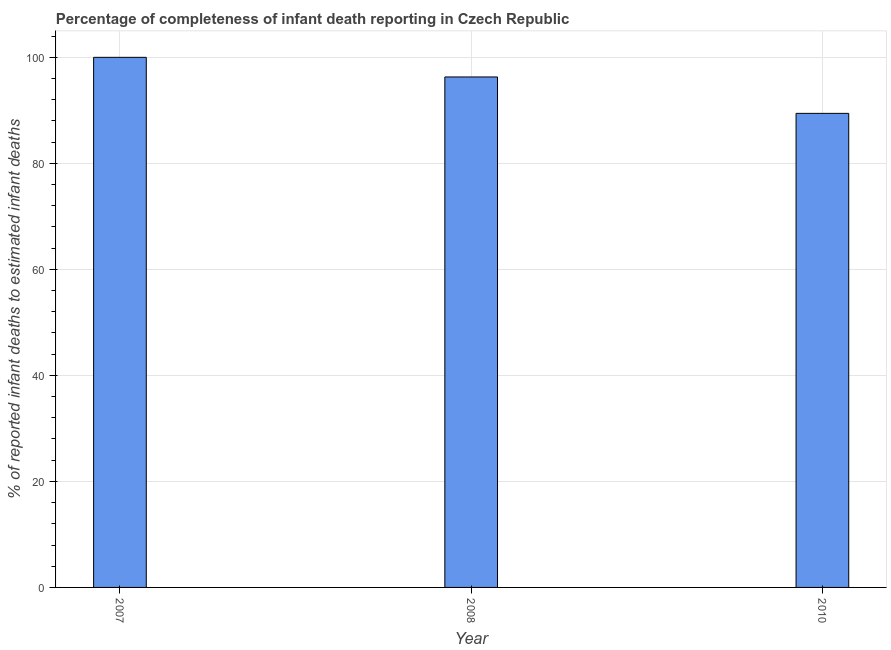Does the graph contain grids?
Keep it short and to the point. Yes. What is the title of the graph?
Offer a very short reply. Percentage of completeness of infant death reporting in Czech Republic. What is the label or title of the Y-axis?
Provide a short and direct response. % of reported infant deaths to estimated infant deaths. What is the completeness of infant death reporting in 2010?
Offer a very short reply. 89.43. Across all years, what is the maximum completeness of infant death reporting?
Ensure brevity in your answer.  100. Across all years, what is the minimum completeness of infant death reporting?
Your response must be concise. 89.43. In which year was the completeness of infant death reporting minimum?
Make the answer very short. 2010. What is the sum of the completeness of infant death reporting?
Offer a terse response. 285.72. What is the difference between the completeness of infant death reporting in 2007 and 2010?
Ensure brevity in your answer.  10.57. What is the average completeness of infant death reporting per year?
Your answer should be very brief. 95.24. What is the median completeness of infant death reporting?
Ensure brevity in your answer.  96.3. Do a majority of the years between 2008 and 2010 (inclusive) have completeness of infant death reporting greater than 64 %?
Provide a succinct answer. Yes. What is the ratio of the completeness of infant death reporting in 2007 to that in 2008?
Provide a succinct answer. 1.04. Is the difference between the completeness of infant death reporting in 2008 and 2010 greater than the difference between any two years?
Offer a very short reply. No. What is the difference between the highest and the second highest completeness of infant death reporting?
Your answer should be very brief. 3.7. Is the sum of the completeness of infant death reporting in 2007 and 2010 greater than the maximum completeness of infant death reporting across all years?
Your answer should be compact. Yes. What is the difference between the highest and the lowest completeness of infant death reporting?
Give a very brief answer. 10.57. Are the values on the major ticks of Y-axis written in scientific E-notation?
Offer a terse response. No. What is the % of reported infant deaths to estimated infant deaths of 2008?
Provide a succinct answer. 96.3. What is the % of reported infant deaths to estimated infant deaths of 2010?
Keep it short and to the point. 89.43. What is the difference between the % of reported infant deaths to estimated infant deaths in 2007 and 2008?
Your answer should be compact. 3.7. What is the difference between the % of reported infant deaths to estimated infant deaths in 2007 and 2010?
Give a very brief answer. 10.57. What is the difference between the % of reported infant deaths to estimated infant deaths in 2008 and 2010?
Ensure brevity in your answer.  6.87. What is the ratio of the % of reported infant deaths to estimated infant deaths in 2007 to that in 2008?
Provide a short and direct response. 1.04. What is the ratio of the % of reported infant deaths to estimated infant deaths in 2007 to that in 2010?
Offer a terse response. 1.12. What is the ratio of the % of reported infant deaths to estimated infant deaths in 2008 to that in 2010?
Keep it short and to the point. 1.08. 